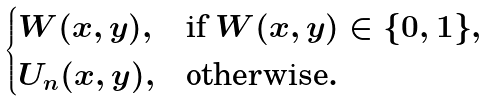<formula> <loc_0><loc_0><loc_500><loc_500>\begin{cases} W ( x , y ) , & \text {if $W(x,y)\in\{0,1\}$} , \\ U _ { n } ( x , y ) , & \text {otherwise} . \end{cases}</formula> 